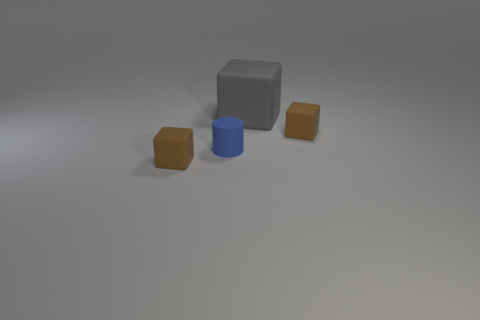Does the object that is to the right of the big gray matte cube have the same material as the brown block that is left of the small cylinder?
Provide a short and direct response. Yes. Is the number of brown matte cubes less than the number of big brown metallic objects?
Offer a terse response. No. There is a brown block to the left of the large matte thing; is there a brown matte thing to the right of it?
Provide a short and direct response. Yes. There is a tiny rubber object that is to the right of the large rubber cube that is right of the small blue matte object; are there any small blue rubber cylinders behind it?
Offer a very short reply. No. There is a rubber object on the left side of the tiny blue matte cylinder; does it have the same shape as the brown thing on the right side of the large matte object?
Provide a short and direct response. Yes. The big cube that is the same material as the tiny blue object is what color?
Ensure brevity in your answer.  Gray. Are there fewer small brown matte objects that are right of the big rubber cube than tiny brown objects?
Give a very brief answer. Yes. There is a brown matte object in front of the tiny brown cube that is behind the small brown matte cube that is to the left of the big gray thing; what size is it?
Keep it short and to the point. Small. Are the cylinder that is left of the big gray rubber cube and the large gray thing made of the same material?
Your response must be concise. Yes. Is there anything else that is the same shape as the blue thing?
Your response must be concise. No. 